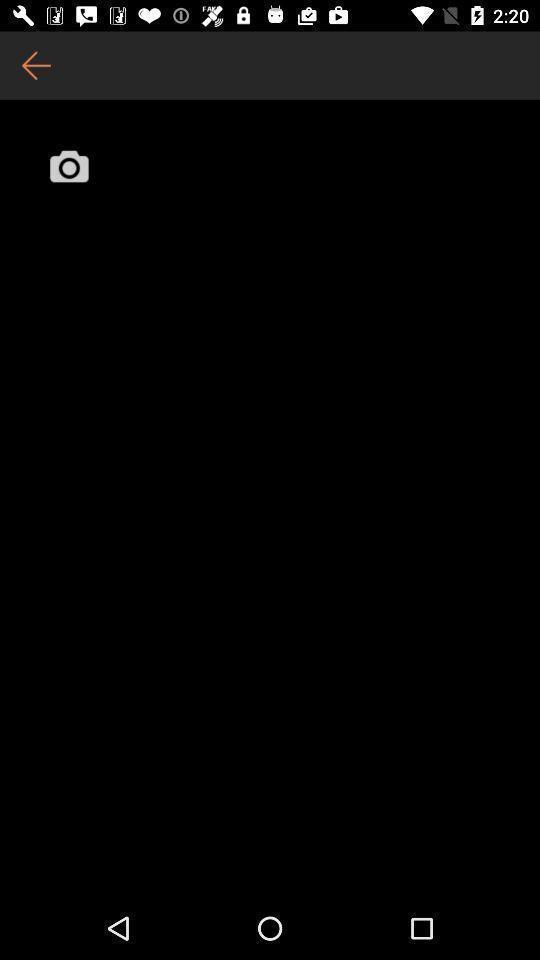What is the overall content of this screenshot? Page showing an icon with a back arrow option. 